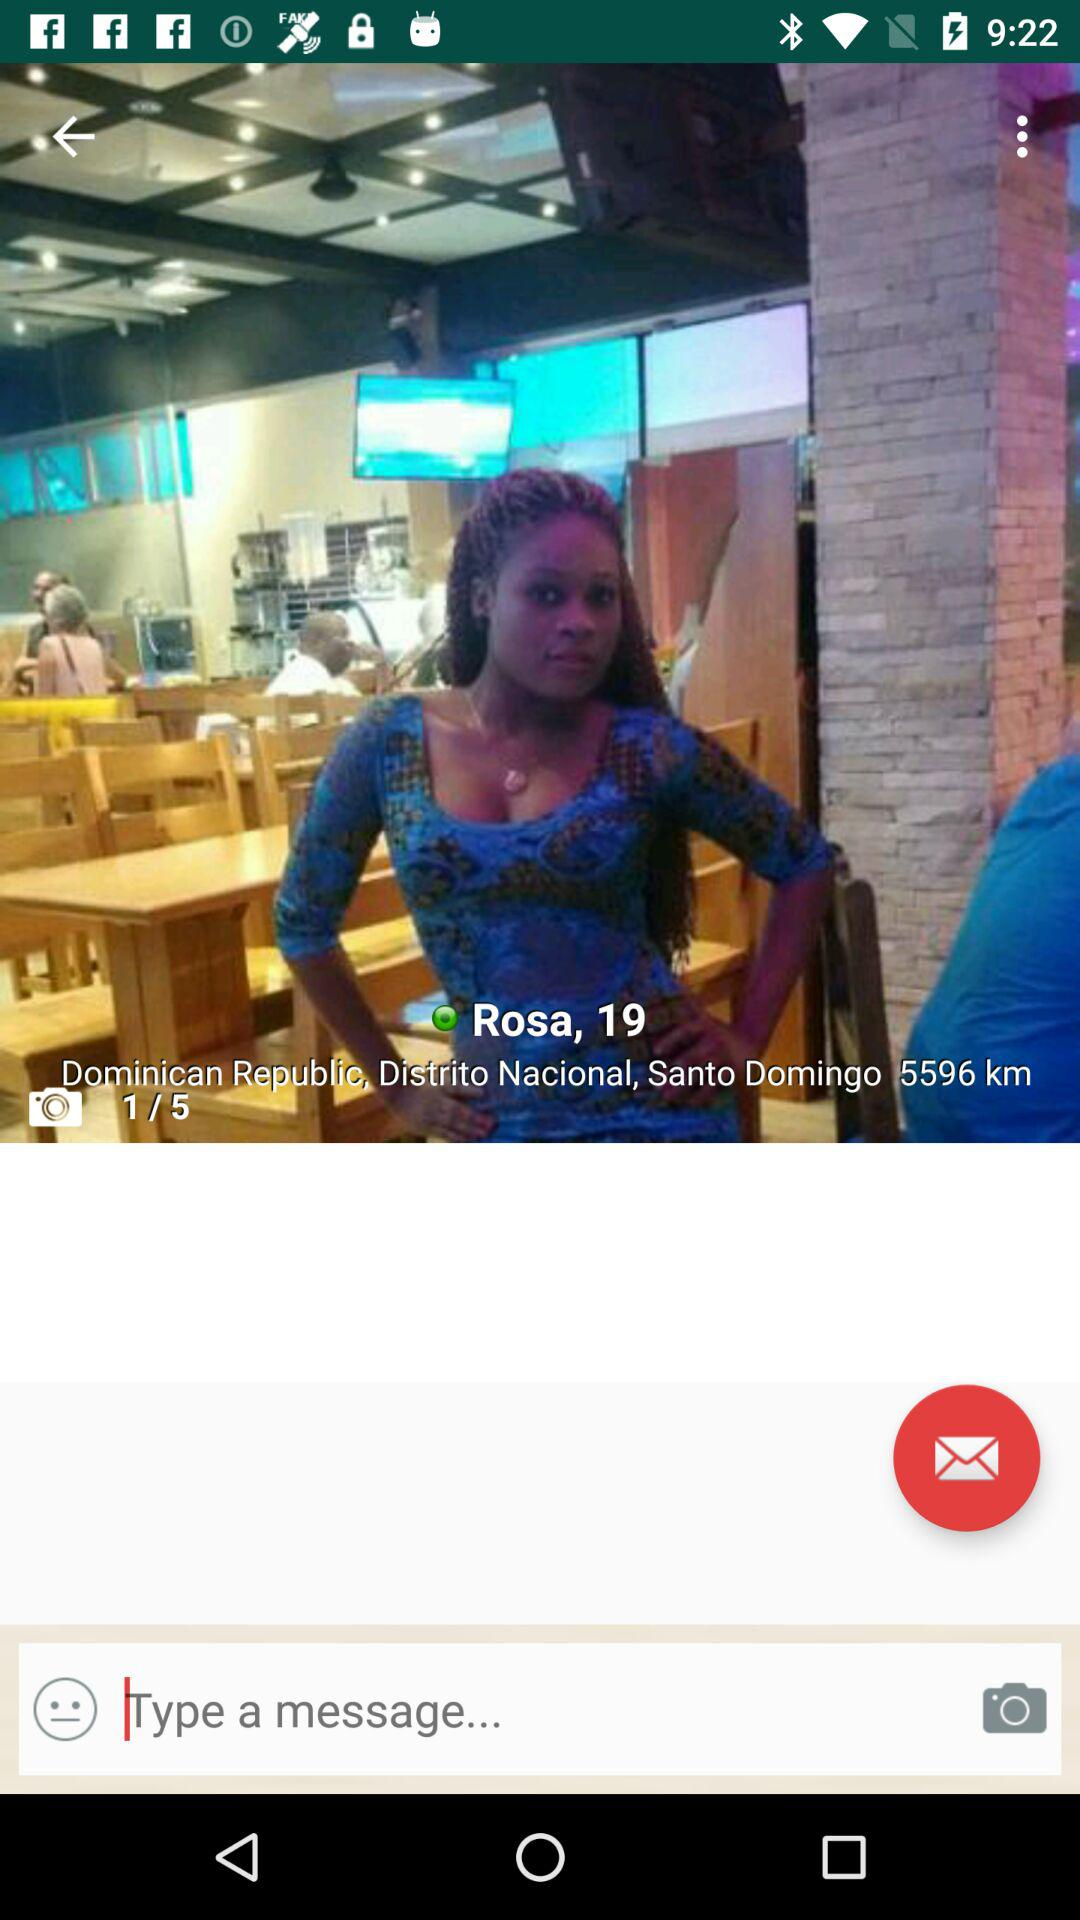What is the age of Rosa? Rosa's age is 19 years old. 